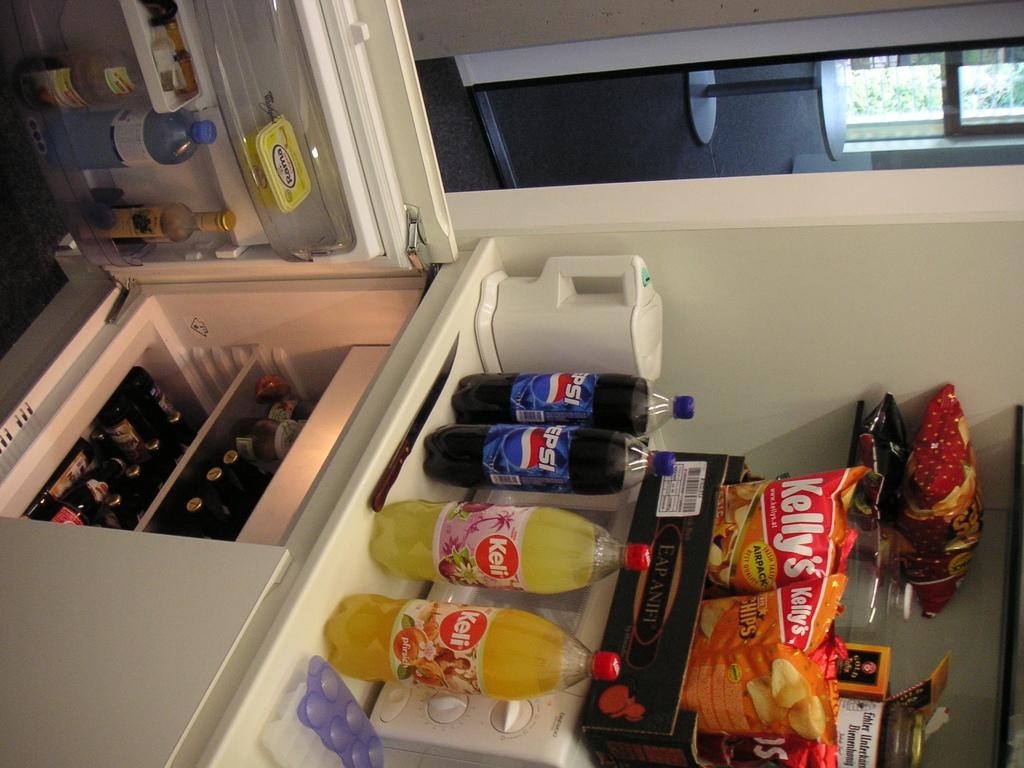<image>
Summarize the visual content of the image. Kelly's chips and other snacks are on a shelf. 